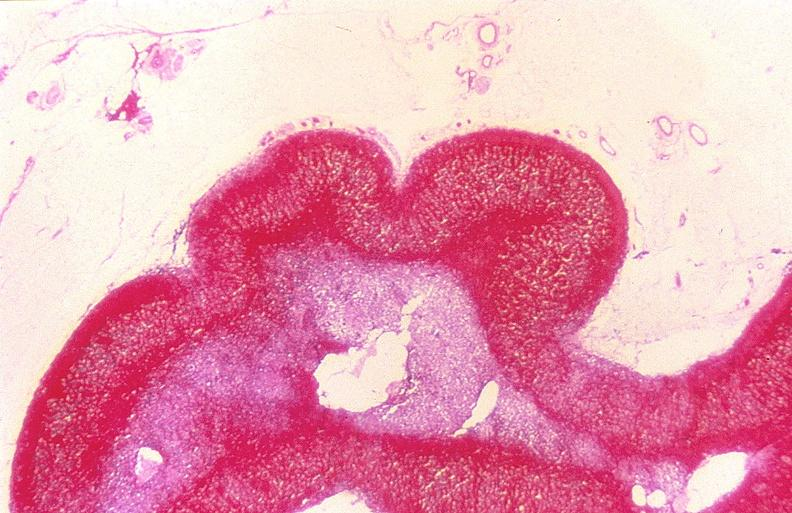where is this part in the figure?
Answer the question using a single word or phrase. Endocrine system 